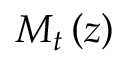<formula> <loc_0><loc_0><loc_500><loc_500>M _ { t } \left ( z \right )</formula> 